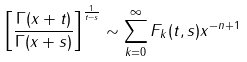<formula> <loc_0><loc_0><loc_500><loc_500>\left [ \frac { \Gamma ( x + t ) } { \Gamma ( x + s ) } \right ] ^ { \frac { 1 } { t - s } } \sim \sum _ { k = 0 } ^ { \infty } F _ { k } ( t , s ) x ^ { - n + 1 }</formula> 